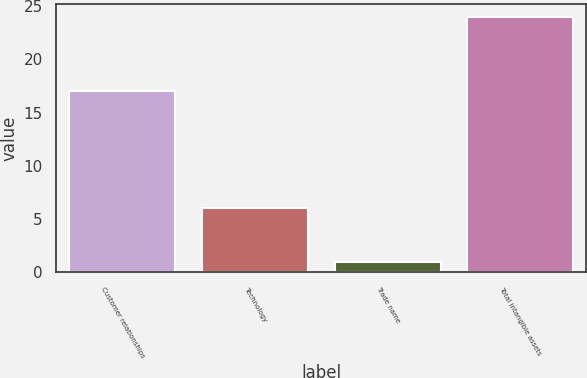Convert chart to OTSL. <chart><loc_0><loc_0><loc_500><loc_500><bar_chart><fcel>Customer relationships<fcel>Technology<fcel>Trade name<fcel>Total intangible assets<nl><fcel>17<fcel>6<fcel>1<fcel>24<nl></chart> 